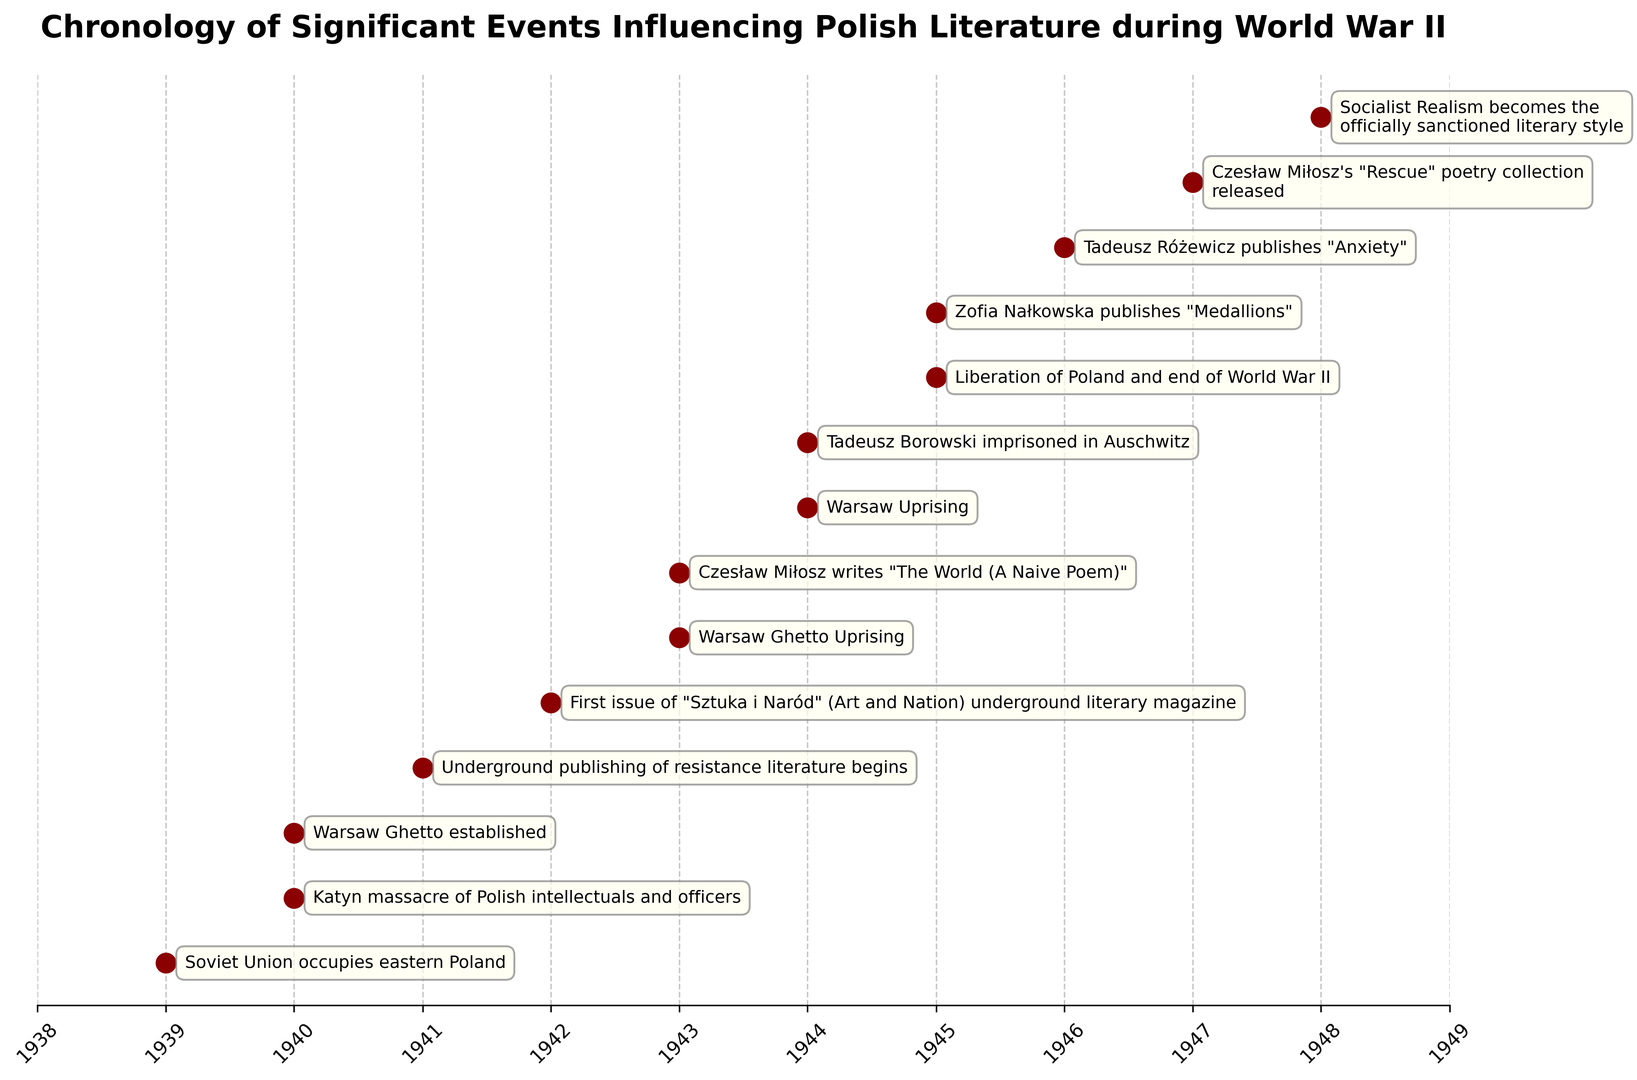What event occurred in 1939? Look at the year 1939 in the plot and note the corresponding event. The event annotated next to 1939 is "Soviet Union occupies eastern Poland."
Answer: Soviet Union occupies eastern Poland What are the two major uprisings mentioned in the timeline? Find the events marked as "uprising" in the plot. These are the "Warsaw Ghetto Uprising" in 1943 and "Warsaw Uprising" in 1944.
Answer: Warsaw Ghetto Uprising and Warsaw Uprising Which event happened earlier: Tadeusz Borowski's imprisonment in Auschwitz or the Liberation of Poland? Compare the years of the two events: Tadeusz Borowski's imprisonment in Auschwitz in 1944 and the Liberation of Poland in 1945. Tadeusz Borowski’s imprisonment happened earlier.
Answer: Tadeusz Borowski's imprisonment in Auschwitz How many years after the Katyn massacre was the Warsaw Uprising? The Katyn massacre occurred in 1940 and the Warsaw Uprising in 1944. The difference between the years is 1944 - 1940 = 4 years.
Answer: 4 years What event followed the Warsaw Ghetto Uprising in the next year? Locate the Warsaw Ghetto Uprising in 1943 and then find the event in 1944. The event in 1944 is the Warsaw Uprising.
Answer: Warsaw Uprising What's the last event recorded in the timeline? Identify the last year in the plot and then look at the corresponding event. The last year is 1948 and the event is "Socialist Realism becomes the officially sanctioned literary style."
Answer: Socialist Realism becomes the officially sanctioned literary style Which event occurred at the midpoint year in the timeline? The timeline spans from 1939 to 1948. The midpoint can be estimated around 1943/1944. Check the events around these years: Warsaw Ghetto Uprising (1943) and Warsaw Uprising (1944).
Answer: Warsaw Ghetto Uprising and Warsaw Uprising In how many events was Czesław Miłosz mentioned? Look at the annotations and count the number of times Czesław Miłosz appears: once in 1943 ("The World (A Naive Poem)") and once in 1947 ("Rescue" poetry collection). So, he’s mentioned in 2 events.
Answer: 2 events 